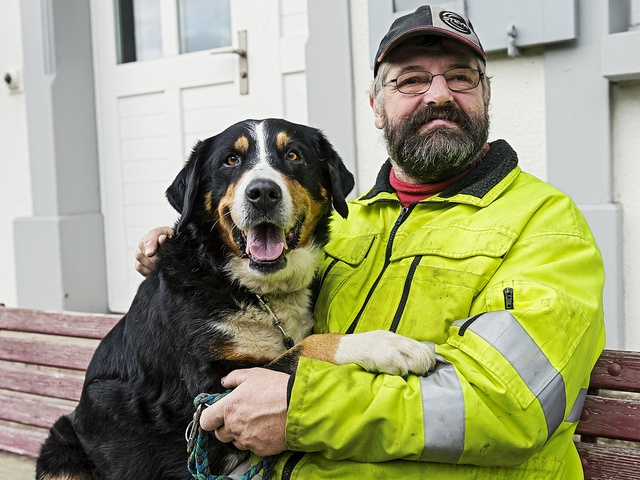Describe the objects in this image and their specific colors. I can see people in lightgray, khaki, black, yellow, and olive tones, dog in lightgray, black, gray, and tan tones, and bench in lightgray, darkgray, brown, and maroon tones in this image. 